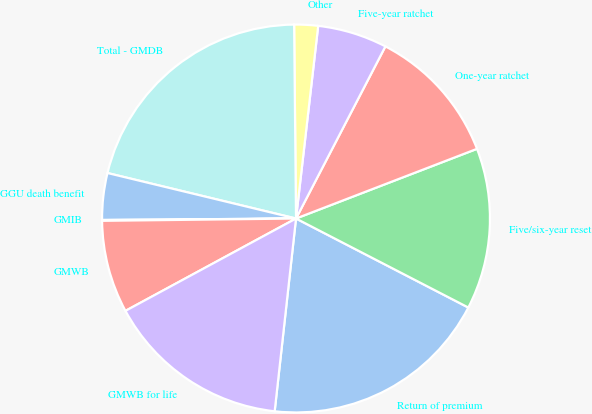Convert chart to OTSL. <chart><loc_0><loc_0><loc_500><loc_500><pie_chart><fcel>Return of premium<fcel>Five/six-year reset<fcel>One-year ratchet<fcel>Five-year ratchet<fcel>Other<fcel>Total - GMDB<fcel>GGU death benefit<fcel>GMIB<fcel>GMWB<fcel>GMWB for life<nl><fcel>19.17%<fcel>13.44%<fcel>11.53%<fcel>5.8%<fcel>1.98%<fcel>21.08%<fcel>3.89%<fcel>0.07%<fcel>7.71%<fcel>15.35%<nl></chart> 